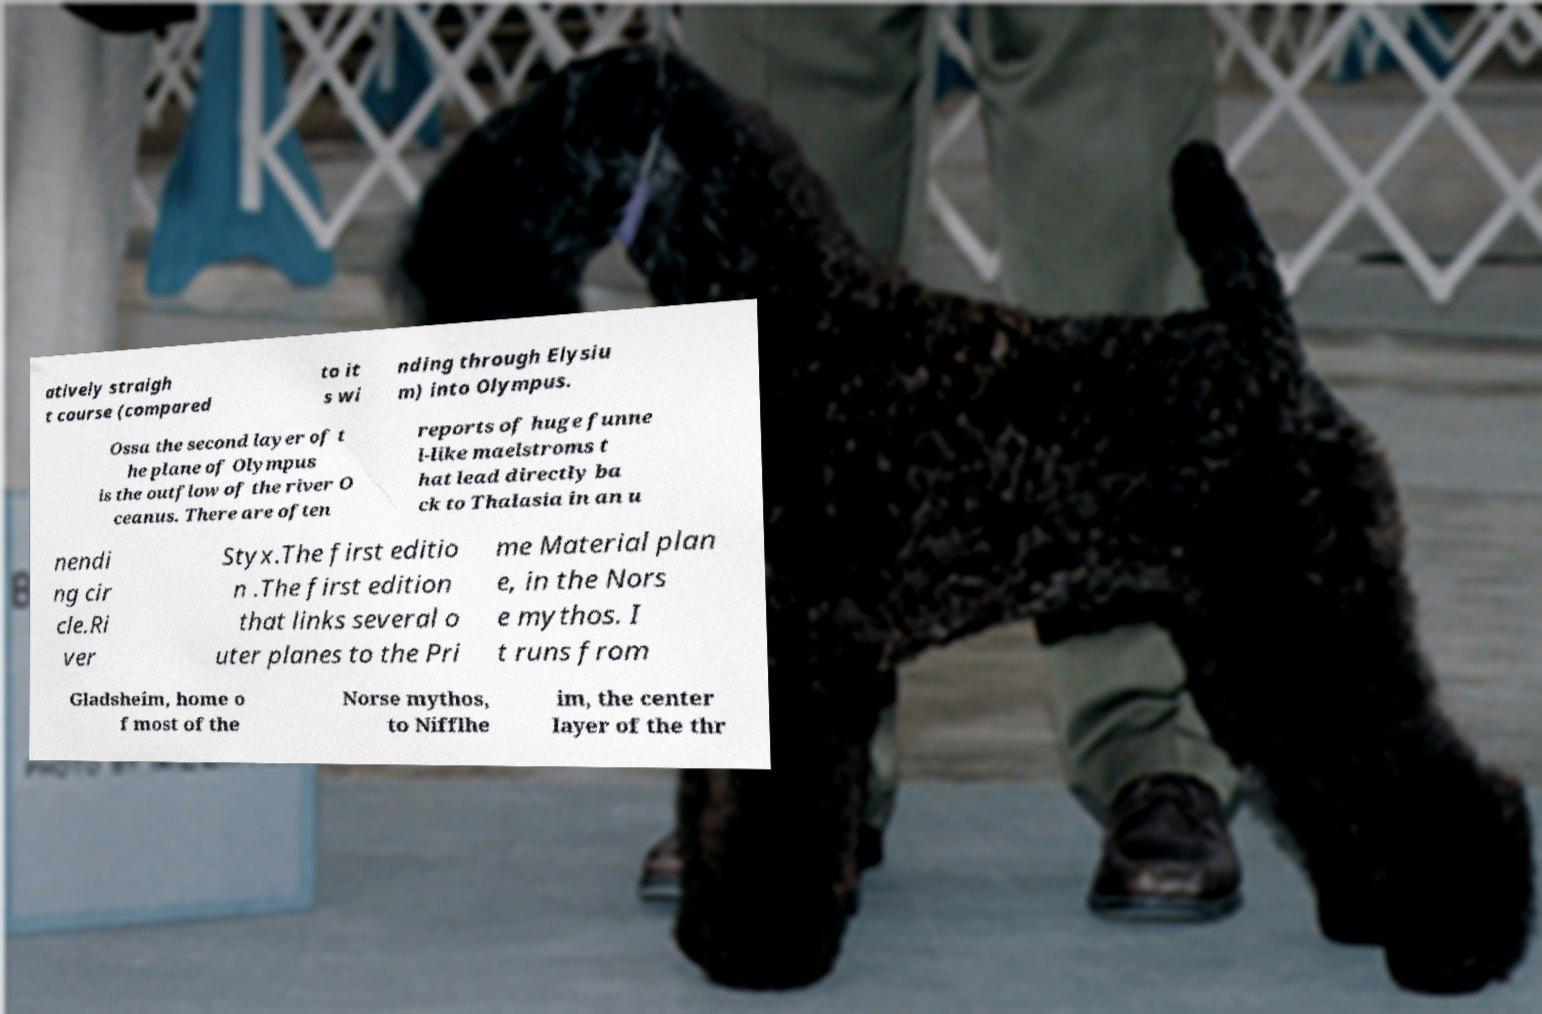Please identify and transcribe the text found in this image. atively straigh t course (compared to it s wi nding through Elysiu m) into Olympus. Ossa the second layer of t he plane of Olympus is the outflow of the river O ceanus. There are often reports of huge funne l-like maelstroms t hat lead directly ba ck to Thalasia in an u nendi ng cir cle.Ri ver Styx.The first editio n .The first edition that links several o uter planes to the Pri me Material plan e, in the Nors e mythos. I t runs from Gladsheim, home o f most of the Norse mythos, to Nifflhe im, the center layer of the thr 